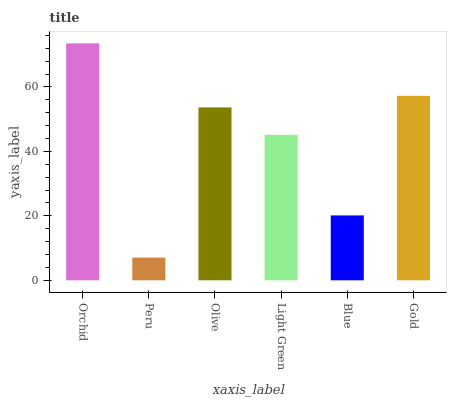Is Peru the minimum?
Answer yes or no. Yes. Is Orchid the maximum?
Answer yes or no. Yes. Is Olive the minimum?
Answer yes or no. No. Is Olive the maximum?
Answer yes or no. No. Is Olive greater than Peru?
Answer yes or no. Yes. Is Peru less than Olive?
Answer yes or no. Yes. Is Peru greater than Olive?
Answer yes or no. No. Is Olive less than Peru?
Answer yes or no. No. Is Olive the high median?
Answer yes or no. Yes. Is Light Green the low median?
Answer yes or no. Yes. Is Blue the high median?
Answer yes or no. No. Is Gold the low median?
Answer yes or no. No. 